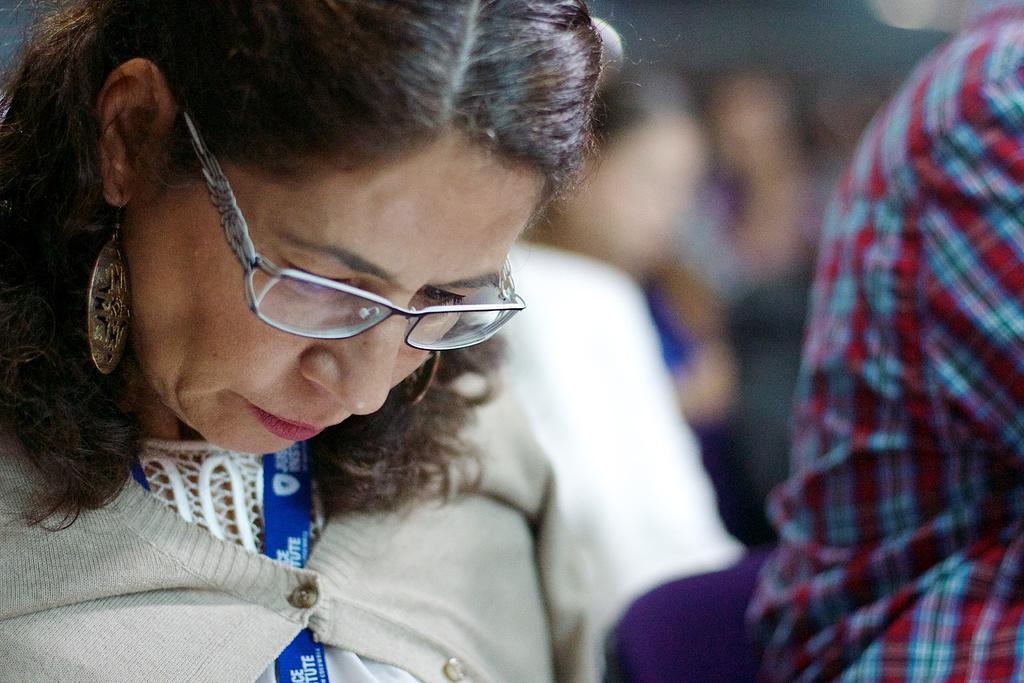In one or two sentences, can you explain what this image depicts? In the picture we can see a woman sitting and bending down and she is wearing a white color woolen shirt and a blue color tag in her neck and beside we can see some person and behind also we can see some people. 